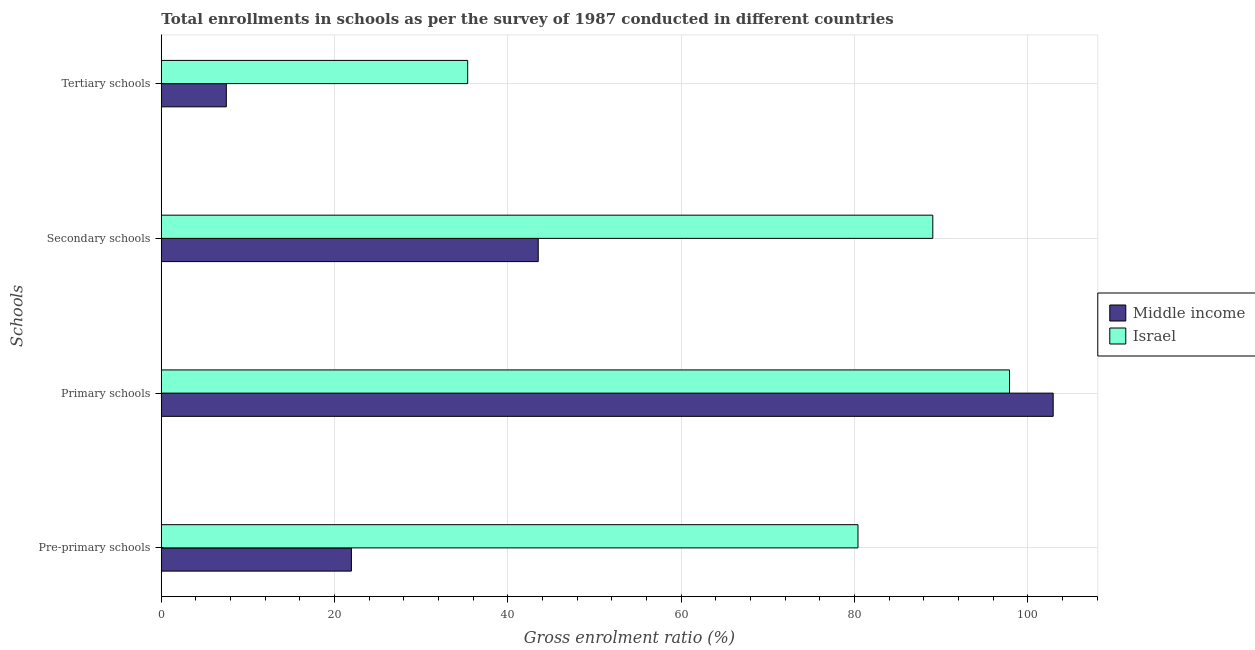How many different coloured bars are there?
Your answer should be compact. 2. Are the number of bars per tick equal to the number of legend labels?
Provide a succinct answer. Yes. How many bars are there on the 1st tick from the top?
Keep it short and to the point. 2. How many bars are there on the 1st tick from the bottom?
Give a very brief answer. 2. What is the label of the 2nd group of bars from the top?
Offer a very short reply. Secondary schools. What is the gross enrolment ratio in tertiary schools in Middle income?
Your response must be concise. 7.5. Across all countries, what is the maximum gross enrolment ratio in pre-primary schools?
Your answer should be compact. 80.39. Across all countries, what is the minimum gross enrolment ratio in primary schools?
Keep it short and to the point. 97.88. In which country was the gross enrolment ratio in pre-primary schools maximum?
Give a very brief answer. Israel. What is the total gross enrolment ratio in primary schools in the graph?
Ensure brevity in your answer.  200.79. What is the difference between the gross enrolment ratio in primary schools in Middle income and that in Israel?
Make the answer very short. 5.04. What is the difference between the gross enrolment ratio in pre-primary schools in Middle income and the gross enrolment ratio in primary schools in Israel?
Ensure brevity in your answer.  -75.94. What is the average gross enrolment ratio in pre-primary schools per country?
Provide a short and direct response. 51.16. What is the difference between the gross enrolment ratio in primary schools and gross enrolment ratio in pre-primary schools in Middle income?
Ensure brevity in your answer.  80.98. What is the ratio of the gross enrolment ratio in tertiary schools in Middle income to that in Israel?
Offer a very short reply. 0.21. Is the difference between the gross enrolment ratio in primary schools in Israel and Middle income greater than the difference between the gross enrolment ratio in pre-primary schools in Israel and Middle income?
Make the answer very short. No. What is the difference between the highest and the second highest gross enrolment ratio in primary schools?
Ensure brevity in your answer.  5.04. What is the difference between the highest and the lowest gross enrolment ratio in secondary schools?
Provide a short and direct response. 45.53. Is the sum of the gross enrolment ratio in secondary schools in Israel and Middle income greater than the maximum gross enrolment ratio in primary schools across all countries?
Provide a succinct answer. Yes. Is it the case that in every country, the sum of the gross enrolment ratio in secondary schools and gross enrolment ratio in tertiary schools is greater than the sum of gross enrolment ratio in pre-primary schools and gross enrolment ratio in primary schools?
Provide a succinct answer. No. What does the 2nd bar from the top in Pre-primary schools represents?
Your response must be concise. Middle income. What does the 1st bar from the bottom in Pre-primary schools represents?
Your answer should be very brief. Middle income. Is it the case that in every country, the sum of the gross enrolment ratio in pre-primary schools and gross enrolment ratio in primary schools is greater than the gross enrolment ratio in secondary schools?
Provide a succinct answer. Yes. How many bars are there?
Provide a succinct answer. 8. Are all the bars in the graph horizontal?
Make the answer very short. Yes. What is the difference between two consecutive major ticks on the X-axis?
Your answer should be very brief. 20. Are the values on the major ticks of X-axis written in scientific E-notation?
Offer a very short reply. No. Does the graph contain any zero values?
Offer a terse response. No. Does the graph contain grids?
Ensure brevity in your answer.  Yes. How many legend labels are there?
Provide a succinct answer. 2. What is the title of the graph?
Your response must be concise. Total enrollments in schools as per the survey of 1987 conducted in different countries. Does "Iran" appear as one of the legend labels in the graph?
Provide a succinct answer. No. What is the label or title of the X-axis?
Provide a short and direct response. Gross enrolment ratio (%). What is the label or title of the Y-axis?
Make the answer very short. Schools. What is the Gross enrolment ratio (%) of Middle income in Pre-primary schools?
Provide a short and direct response. 21.94. What is the Gross enrolment ratio (%) in Israel in Pre-primary schools?
Provide a succinct answer. 80.39. What is the Gross enrolment ratio (%) of Middle income in Primary schools?
Give a very brief answer. 102.91. What is the Gross enrolment ratio (%) of Israel in Primary schools?
Offer a very short reply. 97.88. What is the Gross enrolment ratio (%) of Middle income in Secondary schools?
Give a very brief answer. 43.49. What is the Gross enrolment ratio (%) in Israel in Secondary schools?
Ensure brevity in your answer.  89.02. What is the Gross enrolment ratio (%) of Middle income in Tertiary schools?
Ensure brevity in your answer.  7.5. What is the Gross enrolment ratio (%) of Israel in Tertiary schools?
Offer a terse response. 35.35. Across all Schools, what is the maximum Gross enrolment ratio (%) in Middle income?
Your response must be concise. 102.91. Across all Schools, what is the maximum Gross enrolment ratio (%) of Israel?
Your answer should be very brief. 97.88. Across all Schools, what is the minimum Gross enrolment ratio (%) of Middle income?
Give a very brief answer. 7.5. Across all Schools, what is the minimum Gross enrolment ratio (%) in Israel?
Keep it short and to the point. 35.35. What is the total Gross enrolment ratio (%) of Middle income in the graph?
Your answer should be compact. 175.85. What is the total Gross enrolment ratio (%) in Israel in the graph?
Ensure brevity in your answer.  302.64. What is the difference between the Gross enrolment ratio (%) of Middle income in Pre-primary schools and that in Primary schools?
Your response must be concise. -80.98. What is the difference between the Gross enrolment ratio (%) of Israel in Pre-primary schools and that in Primary schools?
Your answer should be very brief. -17.49. What is the difference between the Gross enrolment ratio (%) in Middle income in Pre-primary schools and that in Secondary schools?
Your answer should be very brief. -21.56. What is the difference between the Gross enrolment ratio (%) in Israel in Pre-primary schools and that in Secondary schools?
Your response must be concise. -8.63. What is the difference between the Gross enrolment ratio (%) in Middle income in Pre-primary schools and that in Tertiary schools?
Provide a short and direct response. 14.43. What is the difference between the Gross enrolment ratio (%) in Israel in Pre-primary schools and that in Tertiary schools?
Offer a terse response. 45.04. What is the difference between the Gross enrolment ratio (%) of Middle income in Primary schools and that in Secondary schools?
Your answer should be compact. 59.42. What is the difference between the Gross enrolment ratio (%) of Israel in Primary schools and that in Secondary schools?
Offer a very short reply. 8.86. What is the difference between the Gross enrolment ratio (%) in Middle income in Primary schools and that in Tertiary schools?
Your answer should be very brief. 95.41. What is the difference between the Gross enrolment ratio (%) of Israel in Primary schools and that in Tertiary schools?
Your response must be concise. 62.53. What is the difference between the Gross enrolment ratio (%) in Middle income in Secondary schools and that in Tertiary schools?
Provide a short and direct response. 35.99. What is the difference between the Gross enrolment ratio (%) in Israel in Secondary schools and that in Tertiary schools?
Your response must be concise. 53.67. What is the difference between the Gross enrolment ratio (%) of Middle income in Pre-primary schools and the Gross enrolment ratio (%) of Israel in Primary schools?
Give a very brief answer. -75.94. What is the difference between the Gross enrolment ratio (%) of Middle income in Pre-primary schools and the Gross enrolment ratio (%) of Israel in Secondary schools?
Your response must be concise. -67.09. What is the difference between the Gross enrolment ratio (%) in Middle income in Pre-primary schools and the Gross enrolment ratio (%) in Israel in Tertiary schools?
Keep it short and to the point. -13.42. What is the difference between the Gross enrolment ratio (%) in Middle income in Primary schools and the Gross enrolment ratio (%) in Israel in Secondary schools?
Provide a short and direct response. 13.89. What is the difference between the Gross enrolment ratio (%) in Middle income in Primary schools and the Gross enrolment ratio (%) in Israel in Tertiary schools?
Your answer should be very brief. 67.56. What is the difference between the Gross enrolment ratio (%) of Middle income in Secondary schools and the Gross enrolment ratio (%) of Israel in Tertiary schools?
Provide a short and direct response. 8.14. What is the average Gross enrolment ratio (%) of Middle income per Schools?
Provide a short and direct response. 43.96. What is the average Gross enrolment ratio (%) of Israel per Schools?
Your answer should be very brief. 75.66. What is the difference between the Gross enrolment ratio (%) of Middle income and Gross enrolment ratio (%) of Israel in Pre-primary schools?
Ensure brevity in your answer.  -58.45. What is the difference between the Gross enrolment ratio (%) in Middle income and Gross enrolment ratio (%) in Israel in Primary schools?
Make the answer very short. 5.04. What is the difference between the Gross enrolment ratio (%) in Middle income and Gross enrolment ratio (%) in Israel in Secondary schools?
Provide a short and direct response. -45.53. What is the difference between the Gross enrolment ratio (%) of Middle income and Gross enrolment ratio (%) of Israel in Tertiary schools?
Keep it short and to the point. -27.85. What is the ratio of the Gross enrolment ratio (%) in Middle income in Pre-primary schools to that in Primary schools?
Offer a terse response. 0.21. What is the ratio of the Gross enrolment ratio (%) of Israel in Pre-primary schools to that in Primary schools?
Your answer should be compact. 0.82. What is the ratio of the Gross enrolment ratio (%) of Middle income in Pre-primary schools to that in Secondary schools?
Provide a short and direct response. 0.5. What is the ratio of the Gross enrolment ratio (%) of Israel in Pre-primary schools to that in Secondary schools?
Your answer should be compact. 0.9. What is the ratio of the Gross enrolment ratio (%) in Middle income in Pre-primary schools to that in Tertiary schools?
Your answer should be compact. 2.92. What is the ratio of the Gross enrolment ratio (%) of Israel in Pre-primary schools to that in Tertiary schools?
Give a very brief answer. 2.27. What is the ratio of the Gross enrolment ratio (%) of Middle income in Primary schools to that in Secondary schools?
Your response must be concise. 2.37. What is the ratio of the Gross enrolment ratio (%) in Israel in Primary schools to that in Secondary schools?
Your answer should be compact. 1.1. What is the ratio of the Gross enrolment ratio (%) of Middle income in Primary schools to that in Tertiary schools?
Make the answer very short. 13.72. What is the ratio of the Gross enrolment ratio (%) of Israel in Primary schools to that in Tertiary schools?
Make the answer very short. 2.77. What is the ratio of the Gross enrolment ratio (%) of Middle income in Secondary schools to that in Tertiary schools?
Your answer should be very brief. 5.8. What is the ratio of the Gross enrolment ratio (%) in Israel in Secondary schools to that in Tertiary schools?
Your answer should be very brief. 2.52. What is the difference between the highest and the second highest Gross enrolment ratio (%) of Middle income?
Make the answer very short. 59.42. What is the difference between the highest and the second highest Gross enrolment ratio (%) in Israel?
Your answer should be compact. 8.86. What is the difference between the highest and the lowest Gross enrolment ratio (%) in Middle income?
Make the answer very short. 95.41. What is the difference between the highest and the lowest Gross enrolment ratio (%) in Israel?
Provide a succinct answer. 62.53. 